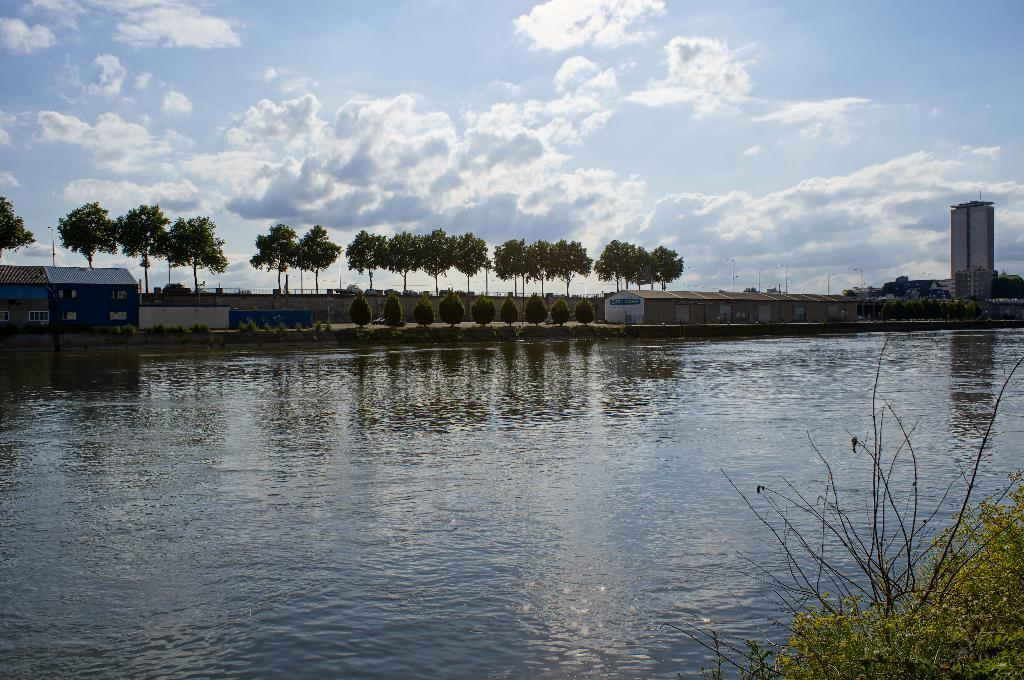What type of natural body of water is present in the image? There is a lake in the picture. What type of vegetation can be seen in the image? There are trees and plants in the picture. What type of human-made structures are visible in the image? There are houses and buildings in the picture. What type of leather is being used to construct the dock in the image? There is no dock present in the image, so there is no leather to be used in its construction. 